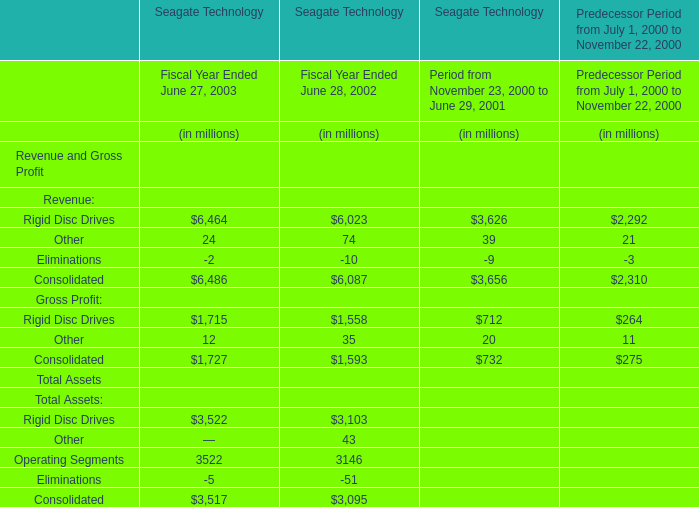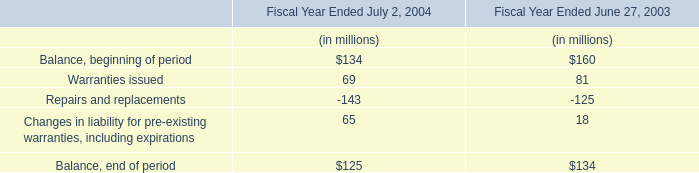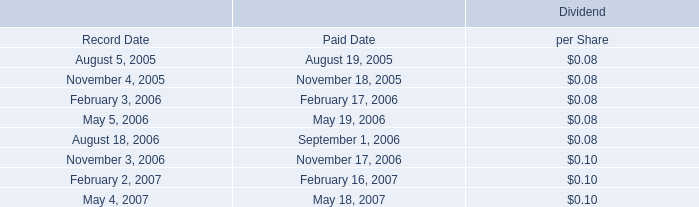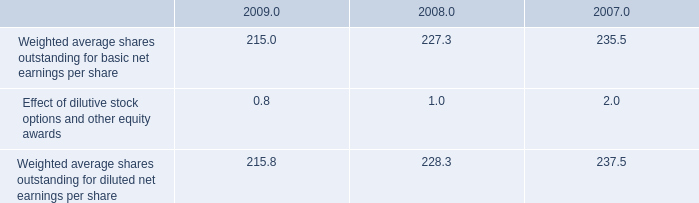What's the current increasing rate of Consolidated for Revenue and Gross Profit? 
Computations: ((6486 - 6087) / 6087)
Answer: 0.06555. 